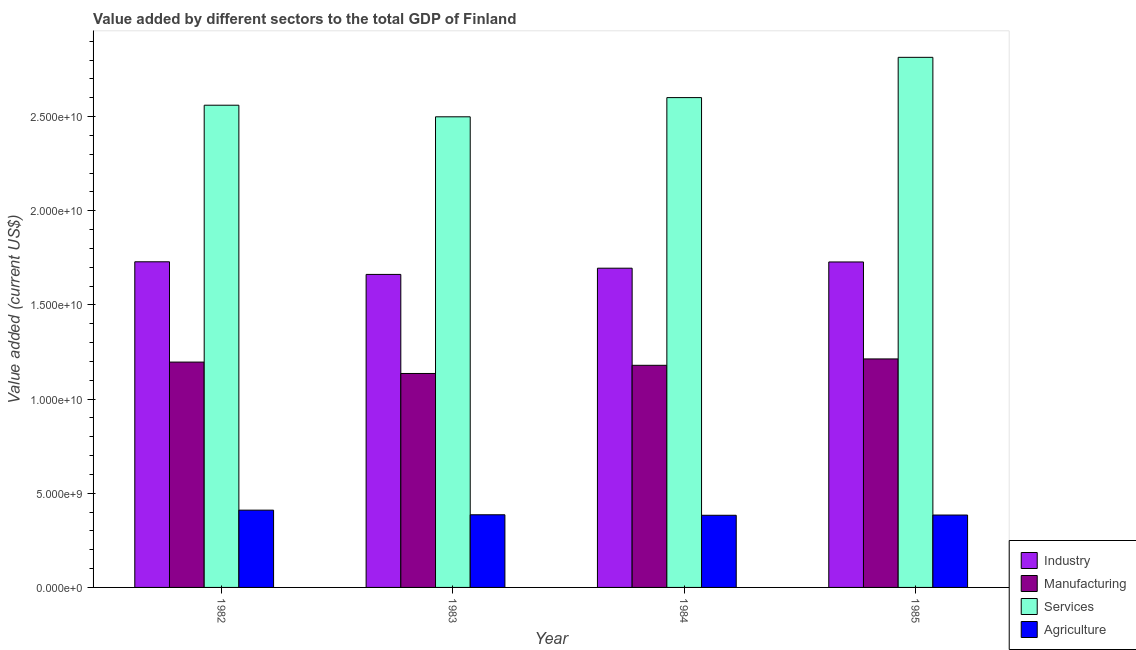How many different coloured bars are there?
Offer a terse response. 4. How many groups of bars are there?
Provide a succinct answer. 4. Are the number of bars on each tick of the X-axis equal?
Your response must be concise. Yes. How many bars are there on the 3rd tick from the right?
Provide a succinct answer. 4. What is the value added by manufacturing sector in 1983?
Ensure brevity in your answer.  1.14e+1. Across all years, what is the maximum value added by services sector?
Provide a succinct answer. 2.81e+1. Across all years, what is the minimum value added by agricultural sector?
Your answer should be compact. 3.83e+09. In which year was the value added by manufacturing sector maximum?
Your answer should be compact. 1985. What is the total value added by manufacturing sector in the graph?
Provide a succinct answer. 4.72e+1. What is the difference between the value added by agricultural sector in 1982 and that in 1984?
Your answer should be very brief. 2.72e+08. What is the difference between the value added by industrial sector in 1985 and the value added by manufacturing sector in 1983?
Make the answer very short. 6.61e+08. What is the average value added by manufacturing sector per year?
Your answer should be very brief. 1.18e+1. In how many years, is the value added by agricultural sector greater than 14000000000 US$?
Your answer should be very brief. 0. What is the ratio of the value added by services sector in 1983 to that in 1984?
Your response must be concise. 0.96. What is the difference between the highest and the second highest value added by services sector?
Ensure brevity in your answer.  2.14e+09. What is the difference between the highest and the lowest value added by agricultural sector?
Your response must be concise. 2.72e+08. In how many years, is the value added by industrial sector greater than the average value added by industrial sector taken over all years?
Your answer should be very brief. 2. Is the sum of the value added by services sector in 1982 and 1985 greater than the maximum value added by manufacturing sector across all years?
Offer a very short reply. Yes. What does the 2nd bar from the left in 1983 represents?
Provide a short and direct response. Manufacturing. What does the 3rd bar from the right in 1983 represents?
Make the answer very short. Manufacturing. Is it the case that in every year, the sum of the value added by industrial sector and value added by manufacturing sector is greater than the value added by services sector?
Offer a terse response. Yes. Are all the bars in the graph horizontal?
Keep it short and to the point. No. How many years are there in the graph?
Make the answer very short. 4. Does the graph contain any zero values?
Make the answer very short. No. Does the graph contain grids?
Offer a very short reply. No. Where does the legend appear in the graph?
Ensure brevity in your answer.  Bottom right. How many legend labels are there?
Offer a very short reply. 4. What is the title of the graph?
Your response must be concise. Value added by different sectors to the total GDP of Finland. What is the label or title of the Y-axis?
Offer a very short reply. Value added (current US$). What is the Value added (current US$) in Industry in 1982?
Your response must be concise. 1.73e+1. What is the Value added (current US$) in Manufacturing in 1982?
Provide a short and direct response. 1.20e+1. What is the Value added (current US$) in Services in 1982?
Provide a succinct answer. 2.56e+1. What is the Value added (current US$) of Agriculture in 1982?
Give a very brief answer. 4.10e+09. What is the Value added (current US$) of Industry in 1983?
Give a very brief answer. 1.66e+1. What is the Value added (current US$) of Manufacturing in 1983?
Make the answer very short. 1.14e+1. What is the Value added (current US$) in Services in 1983?
Ensure brevity in your answer.  2.50e+1. What is the Value added (current US$) in Agriculture in 1983?
Provide a short and direct response. 3.86e+09. What is the Value added (current US$) in Industry in 1984?
Offer a terse response. 1.69e+1. What is the Value added (current US$) of Manufacturing in 1984?
Make the answer very short. 1.18e+1. What is the Value added (current US$) in Services in 1984?
Offer a very short reply. 2.60e+1. What is the Value added (current US$) of Agriculture in 1984?
Keep it short and to the point. 3.83e+09. What is the Value added (current US$) of Industry in 1985?
Make the answer very short. 1.73e+1. What is the Value added (current US$) of Manufacturing in 1985?
Ensure brevity in your answer.  1.21e+1. What is the Value added (current US$) in Services in 1985?
Keep it short and to the point. 2.81e+1. What is the Value added (current US$) of Agriculture in 1985?
Offer a terse response. 3.84e+09. Across all years, what is the maximum Value added (current US$) of Industry?
Offer a terse response. 1.73e+1. Across all years, what is the maximum Value added (current US$) of Manufacturing?
Ensure brevity in your answer.  1.21e+1. Across all years, what is the maximum Value added (current US$) in Services?
Give a very brief answer. 2.81e+1. Across all years, what is the maximum Value added (current US$) of Agriculture?
Your answer should be compact. 4.10e+09. Across all years, what is the minimum Value added (current US$) in Industry?
Offer a very short reply. 1.66e+1. Across all years, what is the minimum Value added (current US$) of Manufacturing?
Give a very brief answer. 1.14e+1. Across all years, what is the minimum Value added (current US$) in Services?
Provide a short and direct response. 2.50e+1. Across all years, what is the minimum Value added (current US$) in Agriculture?
Offer a very short reply. 3.83e+09. What is the total Value added (current US$) in Industry in the graph?
Provide a succinct answer. 6.81e+1. What is the total Value added (current US$) of Manufacturing in the graph?
Offer a very short reply. 4.72e+1. What is the total Value added (current US$) in Services in the graph?
Keep it short and to the point. 1.05e+11. What is the total Value added (current US$) of Agriculture in the graph?
Provide a short and direct response. 1.56e+1. What is the difference between the Value added (current US$) of Industry in 1982 and that in 1983?
Keep it short and to the point. 6.70e+08. What is the difference between the Value added (current US$) of Manufacturing in 1982 and that in 1983?
Make the answer very short. 6.05e+08. What is the difference between the Value added (current US$) of Services in 1982 and that in 1983?
Ensure brevity in your answer.  6.16e+08. What is the difference between the Value added (current US$) of Agriculture in 1982 and that in 1983?
Your answer should be compact. 2.46e+08. What is the difference between the Value added (current US$) of Industry in 1982 and that in 1984?
Keep it short and to the point. 3.41e+08. What is the difference between the Value added (current US$) in Manufacturing in 1982 and that in 1984?
Your response must be concise. 1.71e+08. What is the difference between the Value added (current US$) in Services in 1982 and that in 1984?
Offer a terse response. -4.04e+08. What is the difference between the Value added (current US$) of Agriculture in 1982 and that in 1984?
Keep it short and to the point. 2.72e+08. What is the difference between the Value added (current US$) in Industry in 1982 and that in 1985?
Ensure brevity in your answer.  9.13e+06. What is the difference between the Value added (current US$) in Manufacturing in 1982 and that in 1985?
Give a very brief answer. -1.68e+08. What is the difference between the Value added (current US$) in Services in 1982 and that in 1985?
Provide a short and direct response. -2.54e+09. What is the difference between the Value added (current US$) in Agriculture in 1982 and that in 1985?
Keep it short and to the point. 2.60e+08. What is the difference between the Value added (current US$) of Industry in 1983 and that in 1984?
Give a very brief answer. -3.30e+08. What is the difference between the Value added (current US$) in Manufacturing in 1983 and that in 1984?
Provide a short and direct response. -4.34e+08. What is the difference between the Value added (current US$) of Services in 1983 and that in 1984?
Provide a short and direct response. -1.02e+09. What is the difference between the Value added (current US$) in Agriculture in 1983 and that in 1984?
Your answer should be compact. 2.61e+07. What is the difference between the Value added (current US$) in Industry in 1983 and that in 1985?
Provide a succinct answer. -6.61e+08. What is the difference between the Value added (current US$) in Manufacturing in 1983 and that in 1985?
Your answer should be compact. -7.73e+08. What is the difference between the Value added (current US$) of Services in 1983 and that in 1985?
Provide a succinct answer. -3.16e+09. What is the difference between the Value added (current US$) in Agriculture in 1983 and that in 1985?
Make the answer very short. 1.37e+07. What is the difference between the Value added (current US$) of Industry in 1984 and that in 1985?
Offer a terse response. -3.31e+08. What is the difference between the Value added (current US$) in Manufacturing in 1984 and that in 1985?
Offer a terse response. -3.39e+08. What is the difference between the Value added (current US$) in Services in 1984 and that in 1985?
Offer a terse response. -2.14e+09. What is the difference between the Value added (current US$) of Agriculture in 1984 and that in 1985?
Provide a succinct answer. -1.24e+07. What is the difference between the Value added (current US$) of Industry in 1982 and the Value added (current US$) of Manufacturing in 1983?
Give a very brief answer. 5.93e+09. What is the difference between the Value added (current US$) in Industry in 1982 and the Value added (current US$) in Services in 1983?
Keep it short and to the point. -7.70e+09. What is the difference between the Value added (current US$) of Industry in 1982 and the Value added (current US$) of Agriculture in 1983?
Keep it short and to the point. 1.34e+1. What is the difference between the Value added (current US$) of Manufacturing in 1982 and the Value added (current US$) of Services in 1983?
Provide a succinct answer. -1.30e+1. What is the difference between the Value added (current US$) of Manufacturing in 1982 and the Value added (current US$) of Agriculture in 1983?
Your answer should be compact. 8.11e+09. What is the difference between the Value added (current US$) in Services in 1982 and the Value added (current US$) in Agriculture in 1983?
Offer a very short reply. 2.17e+1. What is the difference between the Value added (current US$) in Industry in 1982 and the Value added (current US$) in Manufacturing in 1984?
Provide a short and direct response. 5.50e+09. What is the difference between the Value added (current US$) of Industry in 1982 and the Value added (current US$) of Services in 1984?
Provide a short and direct response. -8.72e+09. What is the difference between the Value added (current US$) in Industry in 1982 and the Value added (current US$) in Agriculture in 1984?
Provide a succinct answer. 1.35e+1. What is the difference between the Value added (current US$) of Manufacturing in 1982 and the Value added (current US$) of Services in 1984?
Keep it short and to the point. -1.40e+1. What is the difference between the Value added (current US$) in Manufacturing in 1982 and the Value added (current US$) in Agriculture in 1984?
Keep it short and to the point. 8.13e+09. What is the difference between the Value added (current US$) in Services in 1982 and the Value added (current US$) in Agriculture in 1984?
Keep it short and to the point. 2.18e+1. What is the difference between the Value added (current US$) in Industry in 1982 and the Value added (current US$) in Manufacturing in 1985?
Keep it short and to the point. 5.16e+09. What is the difference between the Value added (current US$) of Industry in 1982 and the Value added (current US$) of Services in 1985?
Offer a terse response. -1.09e+1. What is the difference between the Value added (current US$) in Industry in 1982 and the Value added (current US$) in Agriculture in 1985?
Offer a terse response. 1.34e+1. What is the difference between the Value added (current US$) of Manufacturing in 1982 and the Value added (current US$) of Services in 1985?
Keep it short and to the point. -1.62e+1. What is the difference between the Value added (current US$) in Manufacturing in 1982 and the Value added (current US$) in Agriculture in 1985?
Your response must be concise. 8.12e+09. What is the difference between the Value added (current US$) of Services in 1982 and the Value added (current US$) of Agriculture in 1985?
Keep it short and to the point. 2.18e+1. What is the difference between the Value added (current US$) in Industry in 1983 and the Value added (current US$) in Manufacturing in 1984?
Your answer should be compact. 4.83e+09. What is the difference between the Value added (current US$) in Industry in 1983 and the Value added (current US$) in Services in 1984?
Your answer should be compact. -9.39e+09. What is the difference between the Value added (current US$) in Industry in 1983 and the Value added (current US$) in Agriculture in 1984?
Your answer should be compact. 1.28e+1. What is the difference between the Value added (current US$) of Manufacturing in 1983 and the Value added (current US$) of Services in 1984?
Give a very brief answer. -1.46e+1. What is the difference between the Value added (current US$) of Manufacturing in 1983 and the Value added (current US$) of Agriculture in 1984?
Give a very brief answer. 7.53e+09. What is the difference between the Value added (current US$) in Services in 1983 and the Value added (current US$) in Agriculture in 1984?
Your response must be concise. 2.12e+1. What is the difference between the Value added (current US$) of Industry in 1983 and the Value added (current US$) of Manufacturing in 1985?
Ensure brevity in your answer.  4.49e+09. What is the difference between the Value added (current US$) in Industry in 1983 and the Value added (current US$) in Services in 1985?
Make the answer very short. -1.15e+1. What is the difference between the Value added (current US$) of Industry in 1983 and the Value added (current US$) of Agriculture in 1985?
Offer a terse response. 1.28e+1. What is the difference between the Value added (current US$) of Manufacturing in 1983 and the Value added (current US$) of Services in 1985?
Offer a terse response. -1.68e+1. What is the difference between the Value added (current US$) of Manufacturing in 1983 and the Value added (current US$) of Agriculture in 1985?
Ensure brevity in your answer.  7.51e+09. What is the difference between the Value added (current US$) of Services in 1983 and the Value added (current US$) of Agriculture in 1985?
Give a very brief answer. 2.11e+1. What is the difference between the Value added (current US$) in Industry in 1984 and the Value added (current US$) in Manufacturing in 1985?
Your response must be concise. 4.82e+09. What is the difference between the Value added (current US$) in Industry in 1984 and the Value added (current US$) in Services in 1985?
Offer a very short reply. -1.12e+1. What is the difference between the Value added (current US$) of Industry in 1984 and the Value added (current US$) of Agriculture in 1985?
Provide a succinct answer. 1.31e+1. What is the difference between the Value added (current US$) in Manufacturing in 1984 and the Value added (current US$) in Services in 1985?
Offer a terse response. -1.64e+1. What is the difference between the Value added (current US$) in Manufacturing in 1984 and the Value added (current US$) in Agriculture in 1985?
Provide a succinct answer. 7.95e+09. What is the difference between the Value added (current US$) in Services in 1984 and the Value added (current US$) in Agriculture in 1985?
Ensure brevity in your answer.  2.22e+1. What is the average Value added (current US$) in Industry per year?
Offer a very short reply. 1.70e+1. What is the average Value added (current US$) of Manufacturing per year?
Keep it short and to the point. 1.18e+1. What is the average Value added (current US$) of Services per year?
Keep it short and to the point. 2.62e+1. What is the average Value added (current US$) of Agriculture per year?
Offer a terse response. 3.91e+09. In the year 1982, what is the difference between the Value added (current US$) in Industry and Value added (current US$) in Manufacturing?
Your response must be concise. 5.33e+09. In the year 1982, what is the difference between the Value added (current US$) of Industry and Value added (current US$) of Services?
Give a very brief answer. -8.31e+09. In the year 1982, what is the difference between the Value added (current US$) in Industry and Value added (current US$) in Agriculture?
Your answer should be compact. 1.32e+1. In the year 1982, what is the difference between the Value added (current US$) of Manufacturing and Value added (current US$) of Services?
Provide a succinct answer. -1.36e+1. In the year 1982, what is the difference between the Value added (current US$) of Manufacturing and Value added (current US$) of Agriculture?
Keep it short and to the point. 7.86e+09. In the year 1982, what is the difference between the Value added (current US$) of Services and Value added (current US$) of Agriculture?
Offer a terse response. 2.15e+1. In the year 1983, what is the difference between the Value added (current US$) in Industry and Value added (current US$) in Manufacturing?
Your response must be concise. 5.26e+09. In the year 1983, what is the difference between the Value added (current US$) in Industry and Value added (current US$) in Services?
Give a very brief answer. -8.37e+09. In the year 1983, what is the difference between the Value added (current US$) in Industry and Value added (current US$) in Agriculture?
Give a very brief answer. 1.28e+1. In the year 1983, what is the difference between the Value added (current US$) in Manufacturing and Value added (current US$) in Services?
Your response must be concise. -1.36e+1. In the year 1983, what is the difference between the Value added (current US$) of Manufacturing and Value added (current US$) of Agriculture?
Your answer should be very brief. 7.50e+09. In the year 1983, what is the difference between the Value added (current US$) in Services and Value added (current US$) in Agriculture?
Your answer should be very brief. 2.11e+1. In the year 1984, what is the difference between the Value added (current US$) of Industry and Value added (current US$) of Manufacturing?
Provide a short and direct response. 5.16e+09. In the year 1984, what is the difference between the Value added (current US$) of Industry and Value added (current US$) of Services?
Ensure brevity in your answer.  -9.06e+09. In the year 1984, what is the difference between the Value added (current US$) of Industry and Value added (current US$) of Agriculture?
Give a very brief answer. 1.31e+1. In the year 1984, what is the difference between the Value added (current US$) in Manufacturing and Value added (current US$) in Services?
Offer a very short reply. -1.42e+1. In the year 1984, what is the difference between the Value added (current US$) in Manufacturing and Value added (current US$) in Agriculture?
Keep it short and to the point. 7.96e+09. In the year 1984, what is the difference between the Value added (current US$) of Services and Value added (current US$) of Agriculture?
Keep it short and to the point. 2.22e+1. In the year 1985, what is the difference between the Value added (current US$) of Industry and Value added (current US$) of Manufacturing?
Make the answer very short. 5.15e+09. In the year 1985, what is the difference between the Value added (current US$) in Industry and Value added (current US$) in Services?
Ensure brevity in your answer.  -1.09e+1. In the year 1985, what is the difference between the Value added (current US$) of Industry and Value added (current US$) of Agriculture?
Make the answer very short. 1.34e+1. In the year 1985, what is the difference between the Value added (current US$) in Manufacturing and Value added (current US$) in Services?
Offer a very short reply. -1.60e+1. In the year 1985, what is the difference between the Value added (current US$) of Manufacturing and Value added (current US$) of Agriculture?
Offer a terse response. 8.29e+09. In the year 1985, what is the difference between the Value added (current US$) in Services and Value added (current US$) in Agriculture?
Provide a short and direct response. 2.43e+1. What is the ratio of the Value added (current US$) of Industry in 1982 to that in 1983?
Make the answer very short. 1.04. What is the ratio of the Value added (current US$) of Manufacturing in 1982 to that in 1983?
Keep it short and to the point. 1.05. What is the ratio of the Value added (current US$) in Services in 1982 to that in 1983?
Give a very brief answer. 1.02. What is the ratio of the Value added (current US$) of Agriculture in 1982 to that in 1983?
Keep it short and to the point. 1.06. What is the ratio of the Value added (current US$) of Industry in 1982 to that in 1984?
Keep it short and to the point. 1.02. What is the ratio of the Value added (current US$) of Manufacturing in 1982 to that in 1984?
Provide a short and direct response. 1.01. What is the ratio of the Value added (current US$) in Services in 1982 to that in 1984?
Give a very brief answer. 0.98. What is the ratio of the Value added (current US$) in Agriculture in 1982 to that in 1984?
Keep it short and to the point. 1.07. What is the ratio of the Value added (current US$) in Manufacturing in 1982 to that in 1985?
Offer a terse response. 0.99. What is the ratio of the Value added (current US$) in Services in 1982 to that in 1985?
Ensure brevity in your answer.  0.91. What is the ratio of the Value added (current US$) of Agriculture in 1982 to that in 1985?
Give a very brief answer. 1.07. What is the ratio of the Value added (current US$) of Industry in 1983 to that in 1984?
Make the answer very short. 0.98. What is the ratio of the Value added (current US$) of Manufacturing in 1983 to that in 1984?
Offer a terse response. 0.96. What is the ratio of the Value added (current US$) of Services in 1983 to that in 1984?
Give a very brief answer. 0.96. What is the ratio of the Value added (current US$) of Agriculture in 1983 to that in 1984?
Your response must be concise. 1.01. What is the ratio of the Value added (current US$) in Industry in 1983 to that in 1985?
Your response must be concise. 0.96. What is the ratio of the Value added (current US$) of Manufacturing in 1983 to that in 1985?
Your response must be concise. 0.94. What is the ratio of the Value added (current US$) of Services in 1983 to that in 1985?
Provide a short and direct response. 0.89. What is the ratio of the Value added (current US$) of Industry in 1984 to that in 1985?
Make the answer very short. 0.98. What is the ratio of the Value added (current US$) in Manufacturing in 1984 to that in 1985?
Make the answer very short. 0.97. What is the ratio of the Value added (current US$) of Services in 1984 to that in 1985?
Your answer should be very brief. 0.92. What is the difference between the highest and the second highest Value added (current US$) in Industry?
Your answer should be compact. 9.13e+06. What is the difference between the highest and the second highest Value added (current US$) in Manufacturing?
Offer a terse response. 1.68e+08. What is the difference between the highest and the second highest Value added (current US$) in Services?
Offer a terse response. 2.14e+09. What is the difference between the highest and the second highest Value added (current US$) of Agriculture?
Your answer should be very brief. 2.46e+08. What is the difference between the highest and the lowest Value added (current US$) in Industry?
Your answer should be compact. 6.70e+08. What is the difference between the highest and the lowest Value added (current US$) in Manufacturing?
Your answer should be very brief. 7.73e+08. What is the difference between the highest and the lowest Value added (current US$) in Services?
Provide a succinct answer. 3.16e+09. What is the difference between the highest and the lowest Value added (current US$) in Agriculture?
Provide a short and direct response. 2.72e+08. 